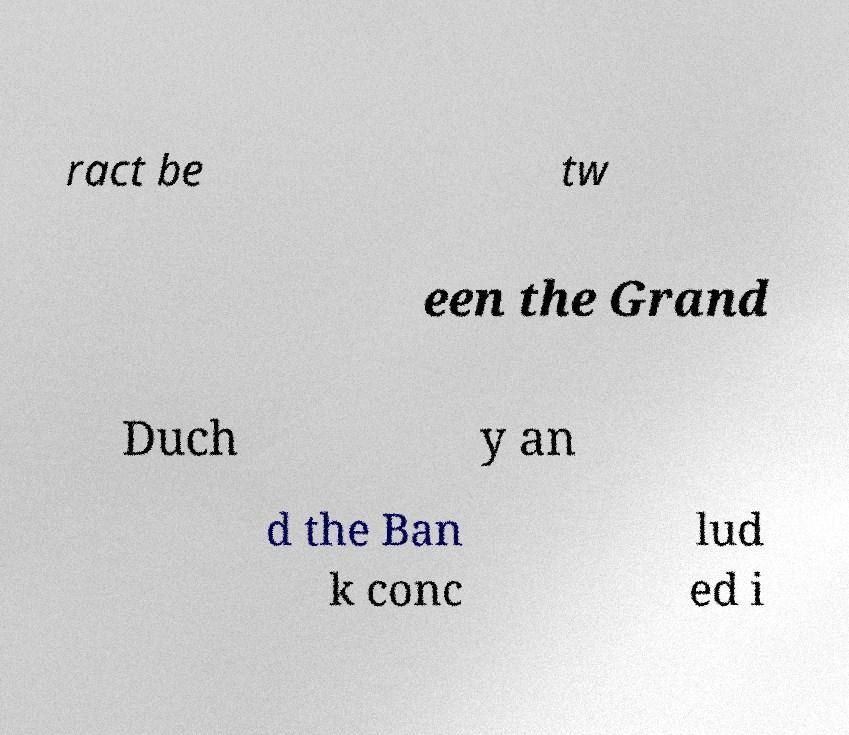Can you accurately transcribe the text from the provided image for me? ract be tw een the Grand Duch y an d the Ban k conc lud ed i 